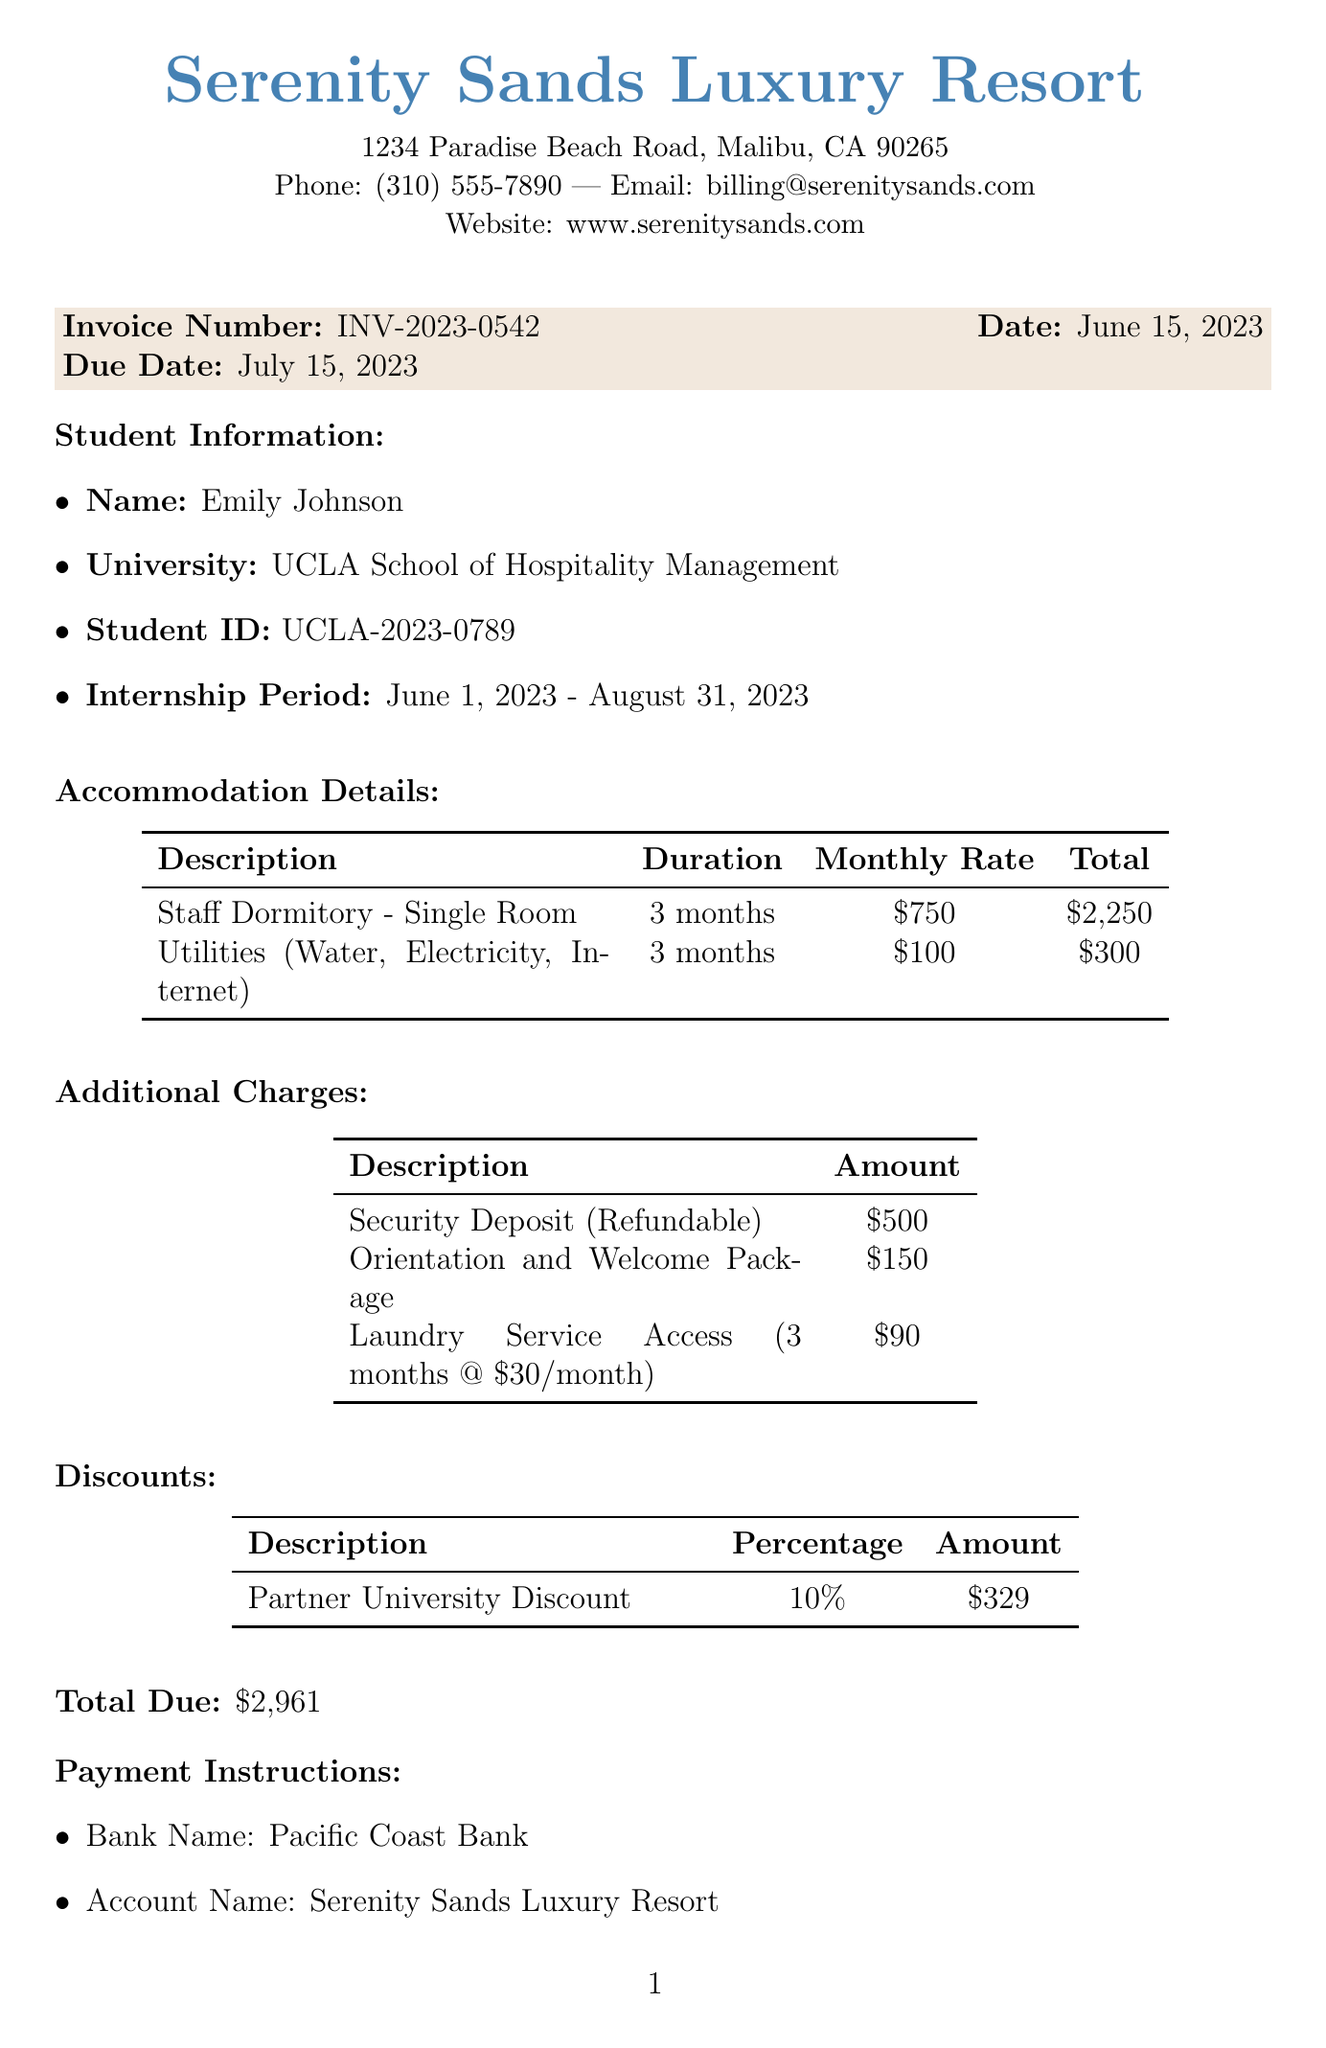What is the student's name? The document states the name of the student intern, which is provided in the student information section.
Answer: Emily Johnson What is the total amount due? The total due is calculated by summing the accommodation details, additional charges, and then applying the discount. The document clearly indicates this total.
Answer: $2,961 When is the invoice due date? The due date of the invoice is explicitly mentioned in the invoice details section of the document.
Answer: July 15, 2023 What is the duration of the internship? The internship period is stated in the student information section of the document.
Answer: June 1, 2023 - August 31, 2023 What university is the student affiliated with? The document includes the name of the university in the student information section.
Answer: UCLA School of Hospitality Management What percentage is the partner university discount? The discount percentage is listed under the discounts section.
Answer: 10% What is included in the additional charges? The document lists various items in the additional charges section, which details specific fees associated with the student's accommodation.
Answer: Security Deposit, Orientation and Welcome Package, Laundry Service Access Who can be contacted for more information? The contact information section provides details about a person who can provide further assistance.
Answer: Sarah Thompson 